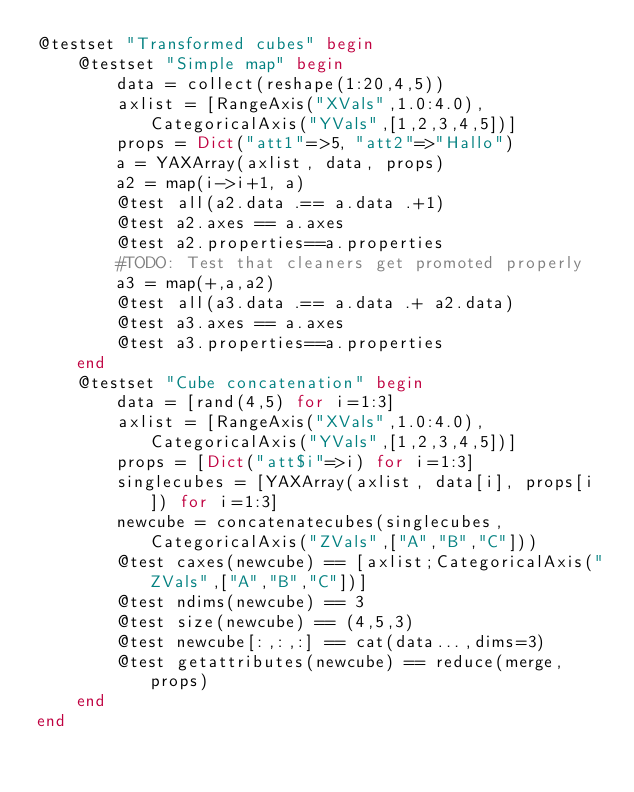Convert code to text. <code><loc_0><loc_0><loc_500><loc_500><_Julia_>@testset "Transformed cubes" begin
    @testset "Simple map" begin
        data = collect(reshape(1:20,4,5))
        axlist = [RangeAxis("XVals",1.0:4.0), CategoricalAxis("YVals",[1,2,3,4,5])]
        props = Dict("att1"=>5, "att2"=>"Hallo")
        a = YAXArray(axlist, data, props)
        a2 = map(i->i+1, a)
        @test all(a2.data .== a.data .+1)
        @test a2.axes == a.axes
        @test a2.properties==a.properties
        #TODO: Test that cleaners get promoted properly
        a3 = map(+,a,a2)
        @test all(a3.data .== a.data .+ a2.data)
        @test a3.axes == a.axes
        @test a3.properties==a.properties
    end
    @testset "Cube concatenation" begin
        data = [rand(4,5) for i=1:3]
        axlist = [RangeAxis("XVals",1.0:4.0), CategoricalAxis("YVals",[1,2,3,4,5])]
        props = [Dict("att$i"=>i) for i=1:3]
        singlecubes = [YAXArray(axlist, data[i], props[i]) for i=1:3]
        newcube = concatenatecubes(singlecubes, CategoricalAxis("ZVals",["A","B","C"]))
        @test caxes(newcube) == [axlist;CategoricalAxis("ZVals",["A","B","C"])]
        @test ndims(newcube) == 3
        @test size(newcube) == (4,5,3)
        @test newcube[:,:,:] == cat(data...,dims=3)
        @test getattributes(newcube) == reduce(merge,props)
    end
end
</code> 